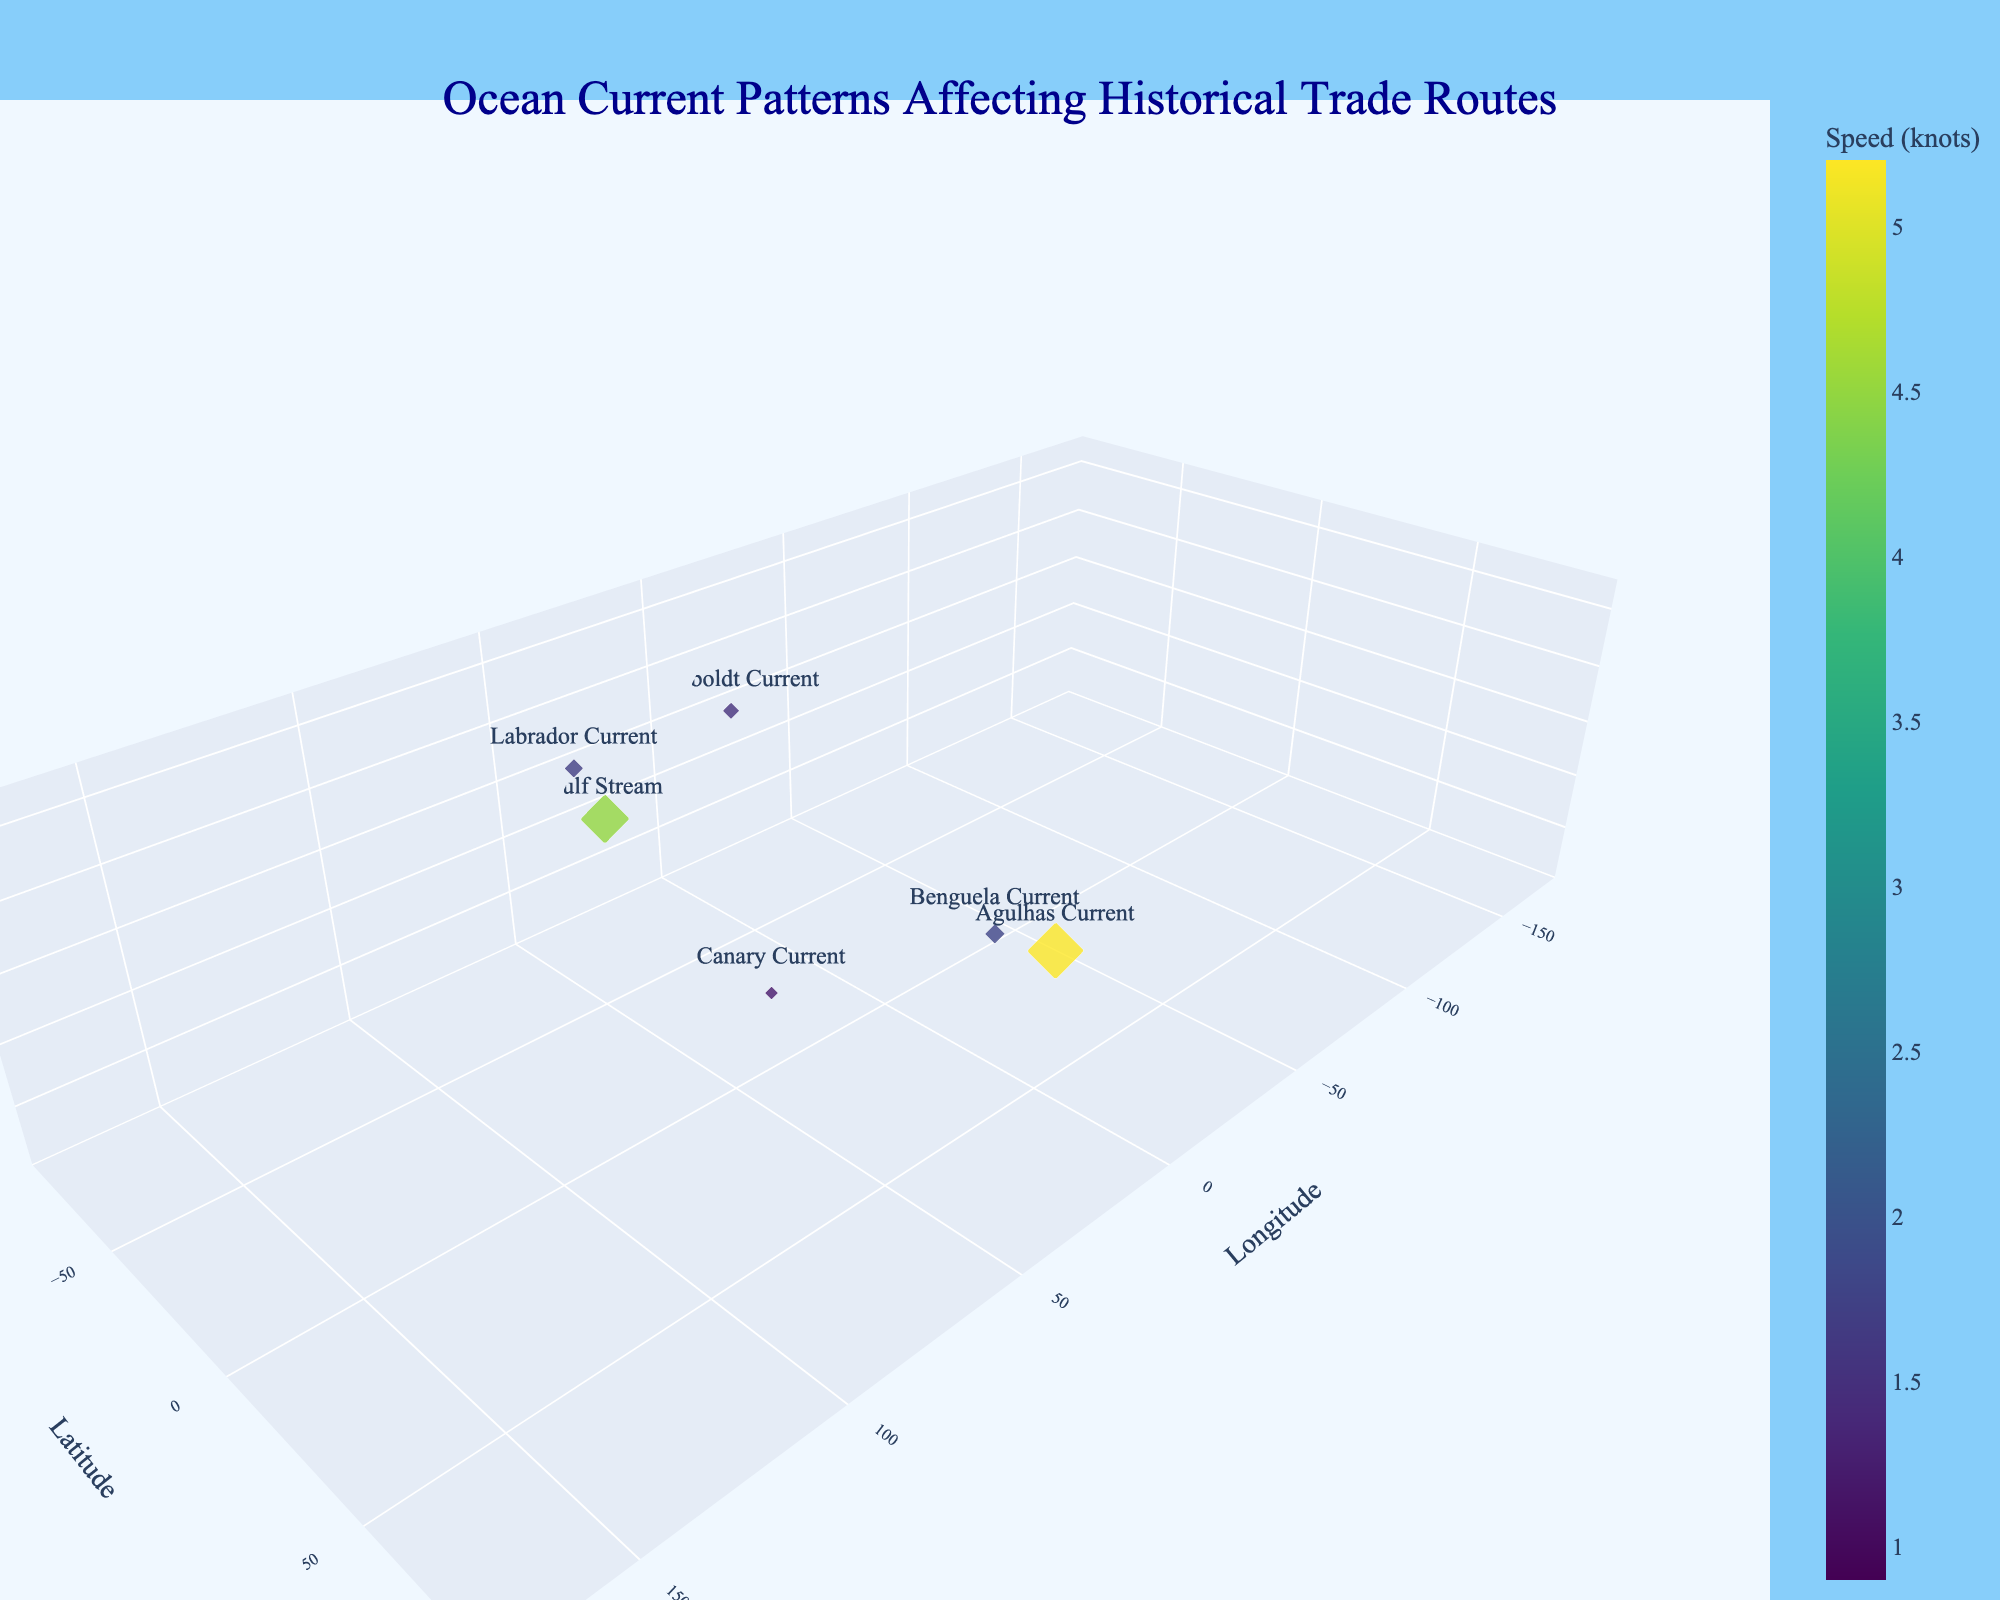Which current has the highest speed? Observing the marker size and color, the largest/brightest marker indicates the fastest current. Locate it and check its label.
Answer: Agulhas Current What's the depth of the Humboldt Current? Find the label "Humboldt Current" in the plot and read its corresponding depth on the Z-axis.
Answer: 300 meters Which ocean current flows in the Southwest direction and is the fastest among similar currents? Identify currents with a Southwest direction by their tooltip and compare their speeds via marker sizes and colors. The fastest one will have the largest and most brightly-colored marker.
Answer: Agulhas Current What is the average speed of the ocean currents in the Southeast direction? Identify all currents labeled with a Southeast direction, then sum their speeds (1.7 and 2.0) and divide by the number of these currents.
Answer: 1.85 knots Which currents are deeper than 300 meters? Examine the Z-axis for depths greater than 300 meters and identify the labeled markers at those depths.
Answer: Labrador Current, Oyashio Current Are there any currents flowing directly North? Check each tooltip or label to see if any currents have the "North" direction.
Answer: Yes, Humboldt Current Which current is closest to the coordinates (-15, 25) in terms of longitude and latitude? Look for markers near the x and y values of -15 and 25 respectively on the plot and verify this with the tooltip information.
Answer: Canary Current How does the speed of the Gulf Stream compare to the Kuroshio Current? Locate both the Gulf Stream and Kuroshio Current markers, compare their sizes and colors which correspond to their speeds. The Gulf Stream should be slightly larger/brighter than the Kuroshio Current.
Answer: Gulf Stream is faster What's the highest depth recorded among the currents? Scan the z-axis for the marker with the greatest depth.
Answer: 500 meters How many currents have speeds less than 2 knots? Identify markers with speeds below 2 knots by their smaller size and duller color, then count these markers.
Answer: 4 currents 